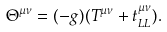<formula> <loc_0><loc_0><loc_500><loc_500>\Theta ^ { \mu \nu } = ( - g ) ( T ^ { \mu \nu } + t _ { L L } ^ { \mu \nu } ) .</formula> 